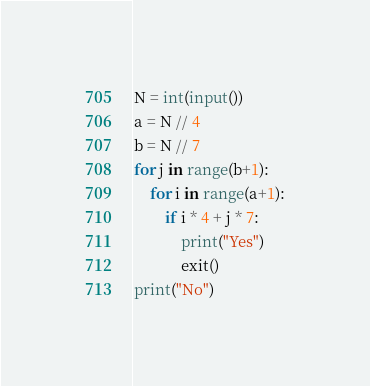Convert code to text. <code><loc_0><loc_0><loc_500><loc_500><_Python_>N = int(input())
a = N // 4
b = N // 7
for j in range(b+1):
    for i in range(a+1):
        if i * 4 + j * 7:
            print("Yes")
            exit()
print("No")
</code> 